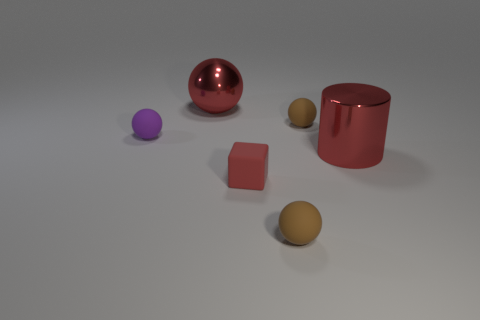Add 2 large cyan matte cylinders. How many objects exist? 8 Subtract all balls. How many objects are left? 2 Subtract 0 gray cubes. How many objects are left? 6 Subtract all green blocks. Subtract all purple things. How many objects are left? 5 Add 5 small red matte things. How many small red matte things are left? 6 Add 3 red things. How many red things exist? 6 